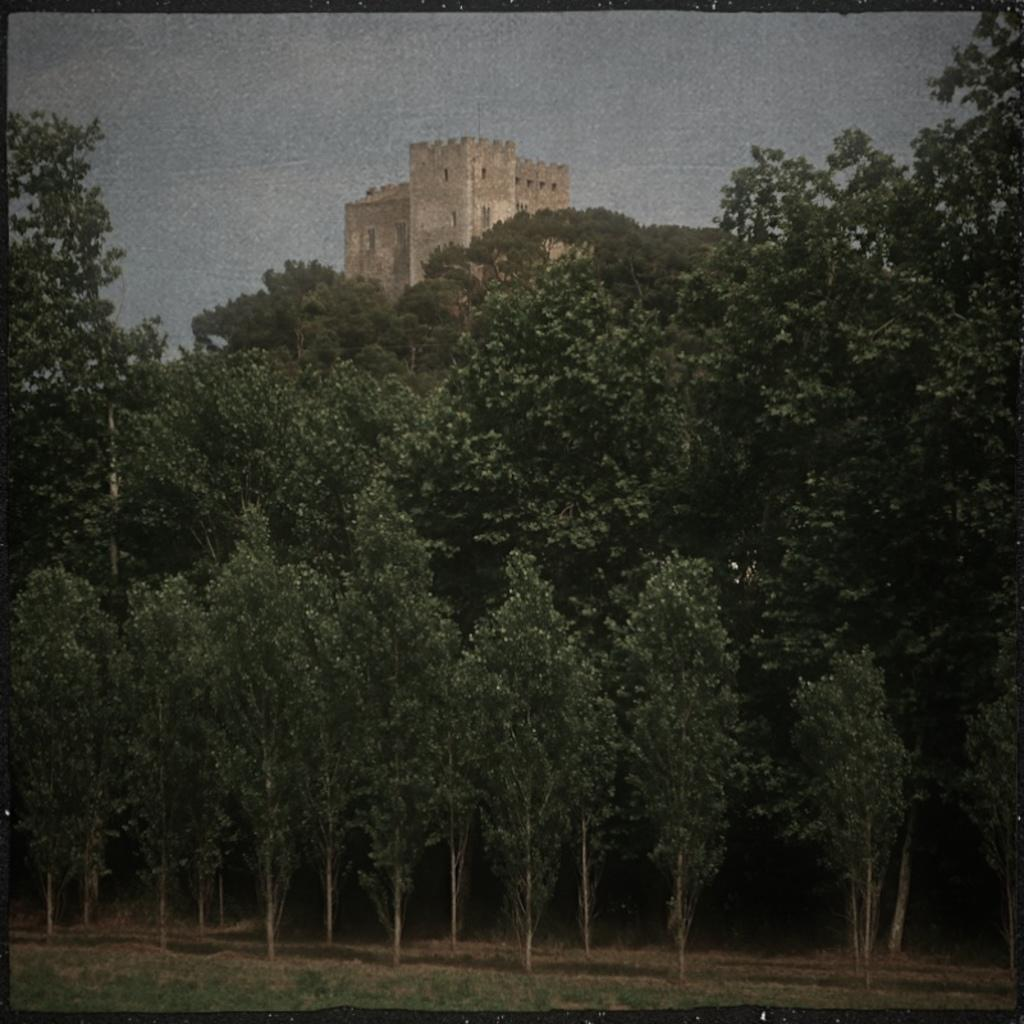What type of vegetation can be seen in the image? There are trees in the image. What type of structure is visible in the image? There is a building in the image. What is covering the ground in the image? Grass is present on the ground in the image. What is the condition of the sky in the image? The sky is cloudy in the image. What type of company is conducting business in the image? There is no company or business activity present in the image. Are there any machines visible in the image? There are no machines present in the image. 